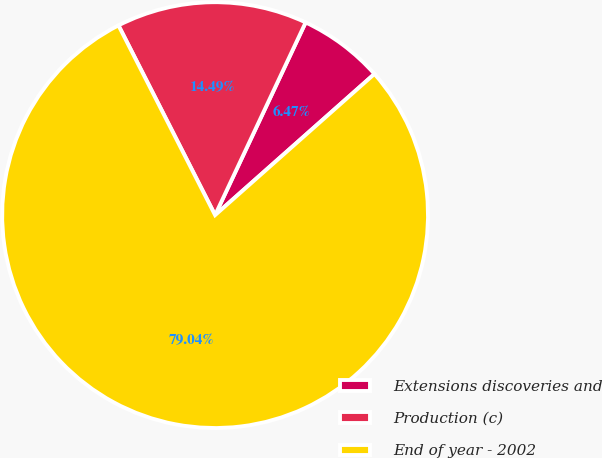Convert chart. <chart><loc_0><loc_0><loc_500><loc_500><pie_chart><fcel>Extensions discoveries and<fcel>Production (c)<fcel>End of year - 2002<nl><fcel>6.47%<fcel>14.49%<fcel>79.04%<nl></chart> 